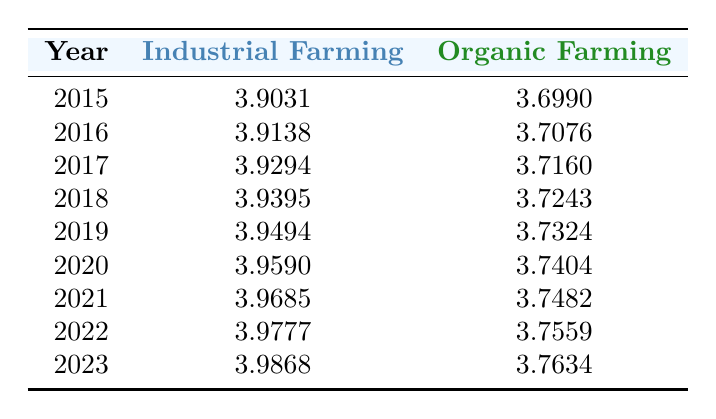What was the water consumption for industrial farming in 2020? From the table, the value listed under Industrial Farming for the year 2020 is 3.9590 (in logarithmic value).
Answer: 3.9590 In which year was the organic farming water consumption highest? By observing the values in the Organic Farming column, the highest value is 3.7634 which corresponds to the year 2023.
Answer: 2023 What is the difference in water consumption between industrial and organic farming in 2019? For 2019, the industrial farming value is 3.9494, while the organic farming value is 3.7324. The difference is calculated as follows: 3.9494 - 3.7324 = 0.2170.
Answer: 0.2170 Is the water consumption for industrial farming increasing every year? By examining the Industrial Farming column, all values show a consistent increase from 2015 to 2023, confirming that water consumption is indeed increasing every year.
Answer: Yes What is the average water consumption for organic farming from 2015 to 2023? To find the average, we first sum the values for organic farming: (3.6990 + 3.7076 + 3.7160 + 3.7243 + 3.7324 + 3.7404 + 3.7482 + 3.7559 + 3.7634) = 33.9062. Then, divide by 9 (the number of years): 33.9062 / 9 = 3.7673.
Answer: 3.7673 By how much did industrial farming water consumption increase from 2015 to 2023? The values are 3.9031 for 2015 and 3.9868 for 2023. The increase is calculated as 3.9868 - 3.9031 = 0.0837.
Answer: 0.0837 Did organic farming consume less water than industrial farming in 2021? In 2021, industrial farming is at 3.9685 and organic farming is at 3.7482. Since 3.7482 is less than 3.9685, the statement is true.
Answer: Yes What was the trend in water consumption for organic farming from 2015 to 2023? By evaluating the values in the Organic Farming column from 3.6990 to 3.7634, we see a steady increase each year, indicating an upward trend.
Answer: Increasing 